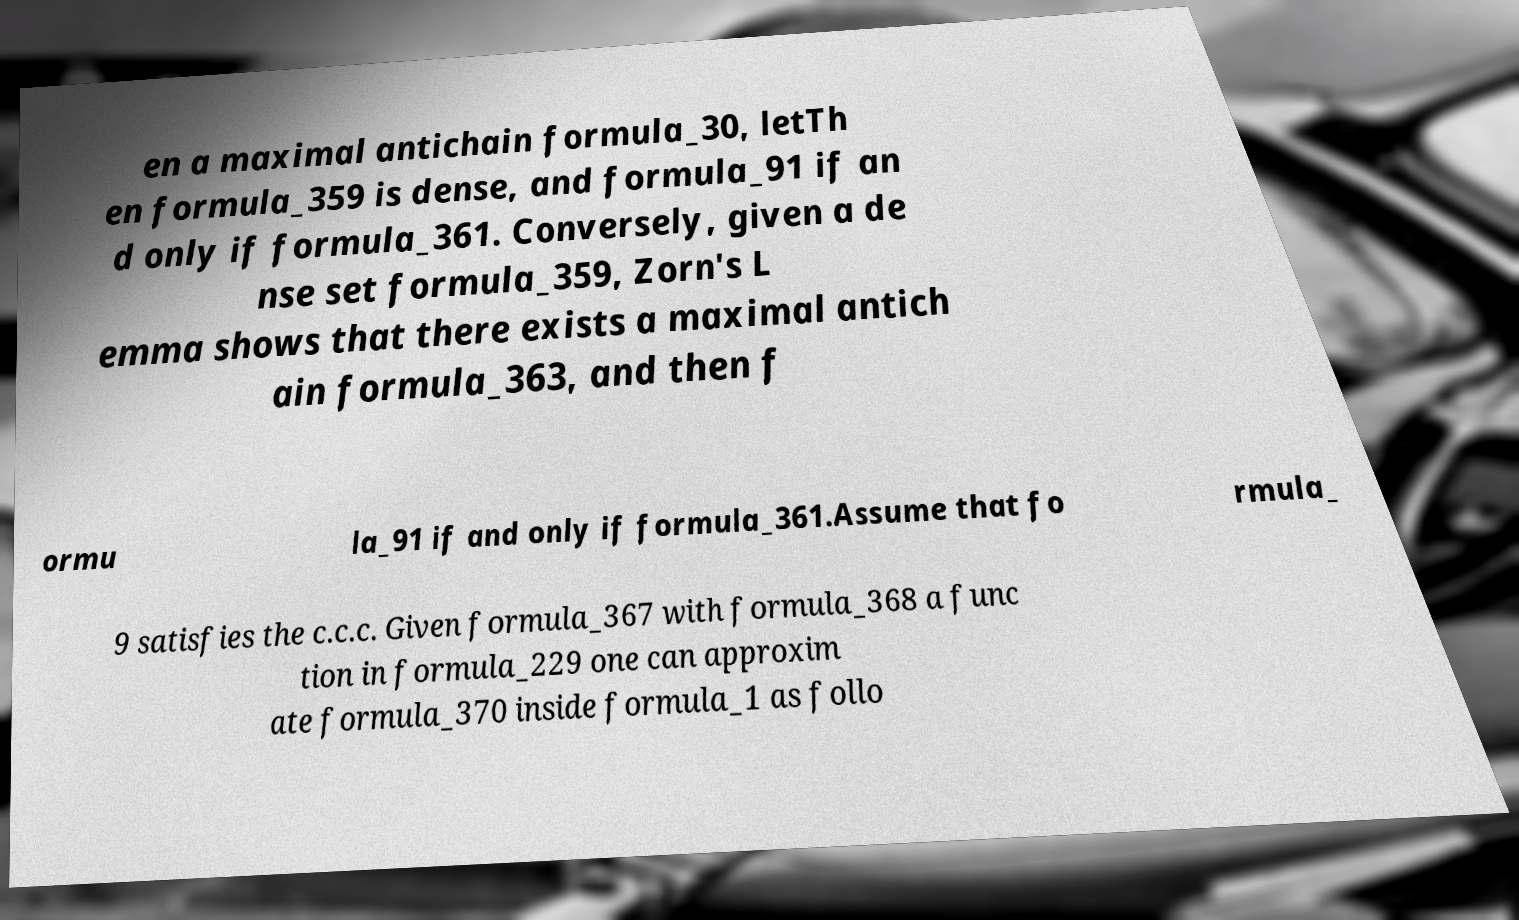Can you read and provide the text displayed in the image?This photo seems to have some interesting text. Can you extract and type it out for me? en a maximal antichain formula_30, letTh en formula_359 is dense, and formula_91 if an d only if formula_361. Conversely, given a de nse set formula_359, Zorn's L emma shows that there exists a maximal antich ain formula_363, and then f ormu la_91 if and only if formula_361.Assume that fo rmula_ 9 satisfies the c.c.c. Given formula_367 with formula_368 a func tion in formula_229 one can approxim ate formula_370 inside formula_1 as follo 